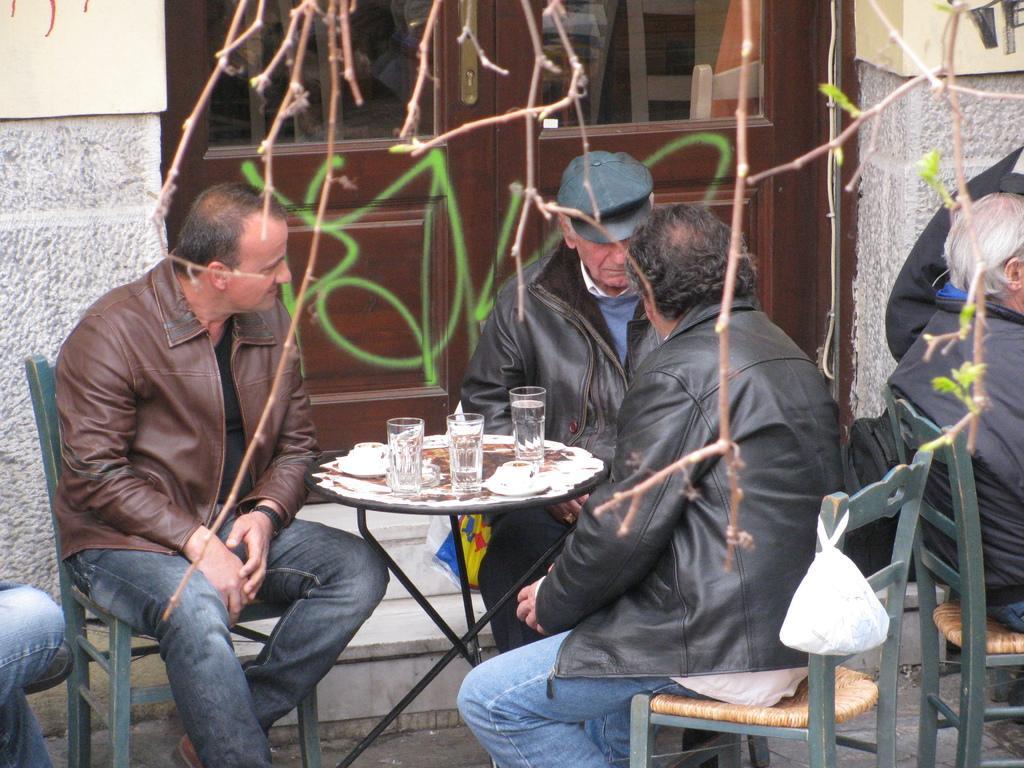Can you describe this image briefly? There are three men sitting on chairs. And there is a table. On the table there are three glasses and some other items. A person wearing a black jacket and blue shirt is wearing a cap. In the background there is a brick wall and a door. On the chair there is a cover. 